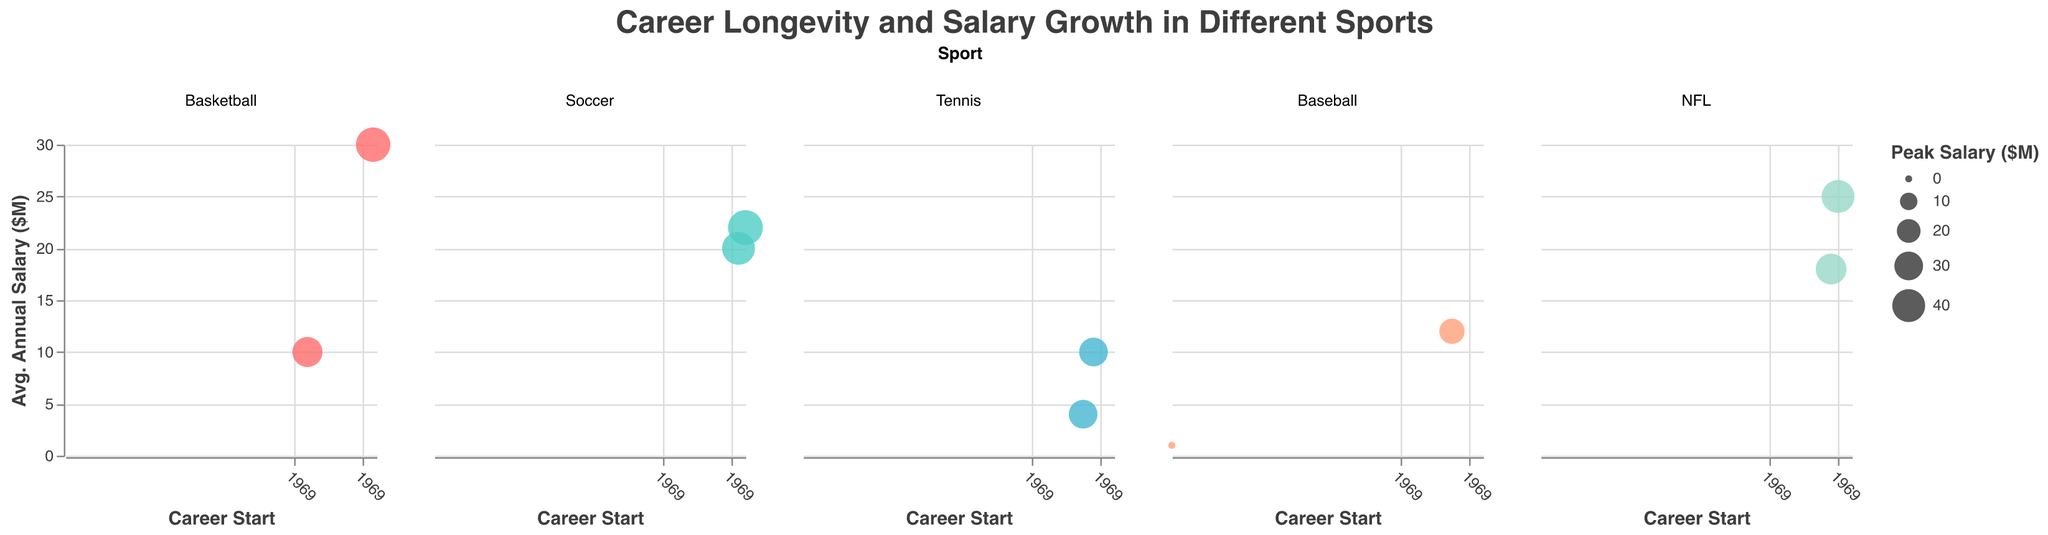What is the title of this figure? The title is displayed at the top of the figure and reads "Career Longevity and Salary Growth in Different Sports".
Answer: Career Longevity and Salary Growth in Different Sports How many different sports are represented in the figure? The figure uses the "facet" feature to categorize data by sport, and it shows columns for Basketball, Soccer, Tennis, Baseball, and NFL. This totals to five different sports.
Answer: Five Which player has the highest peak salary? By examining the bubble sizes, Lionel Messi in Soccer has the largest bubble, corresponding to the highest peak salary of $45 million.
Answer: Lionel Messi What is the axis title for the x-axis in each subplot? Each subplot has the same x-axis title, "Career Start", indicating the starting year of the athletes' careers.
Answer: Career Start On which year axis does Serena Williams have the smallest average annual salary? Serena Williams' career starts in 1995 and ends in 2022. By examining the y-axis of the Tennis subplot, her average annual salary is $4 million, which is the smallest in her subplot.
Answer: 1995-2022 If you plot both starting and retirement years, how many years did each basketball player compete in their career? LeBron James competed from 2003 to 2023, which is 20 years. Michael Jordan played from 1984 to 2003, totaling 19 years.
Answer: LeBron James - 20 years, Michael Jordan - 19 years How does Cristiano Ronaldo's average annual salary compare to Lionel Messi's? In the Soccer subplot, Cristiano Ronaldo has an average annual salary of $20 million while Lionel Messi has $22 million, making Messi's salary $2 million higher than Ronaldo's.
Answer: Lionel Messi's is $2 million higher Which sport has players with the highest average peak salary based on bubble sizes? By comparing the sizes of the bubbles across all subplots, Soccer has the largest bubbles, indicating the highest average peak salary.
Answer: Soccer How does the average annual salary of Tom Brady compare to Derek Jeter? Tom Brady in the NFL subplot has an average annual salary of $25 million, while Derek Jeter in Baseball has $12 million. Therefore, Brady's average salary is $13 million more than Jeter's.
Answer: Tom Brady's is $13 million more Do Tennis players have a higher averaged peak salary than Baseball players? In Tennis, both Serena Williams and Roger Federer’s peak salaries are $30 million each. In Baseball, Derek Jeter's peak salary is $23 million and Babe Ruth's is $0.08 million. The average peak salary for Tennis is higher since both players have $30 million compared to Baseball's average.
Answer: Yes 